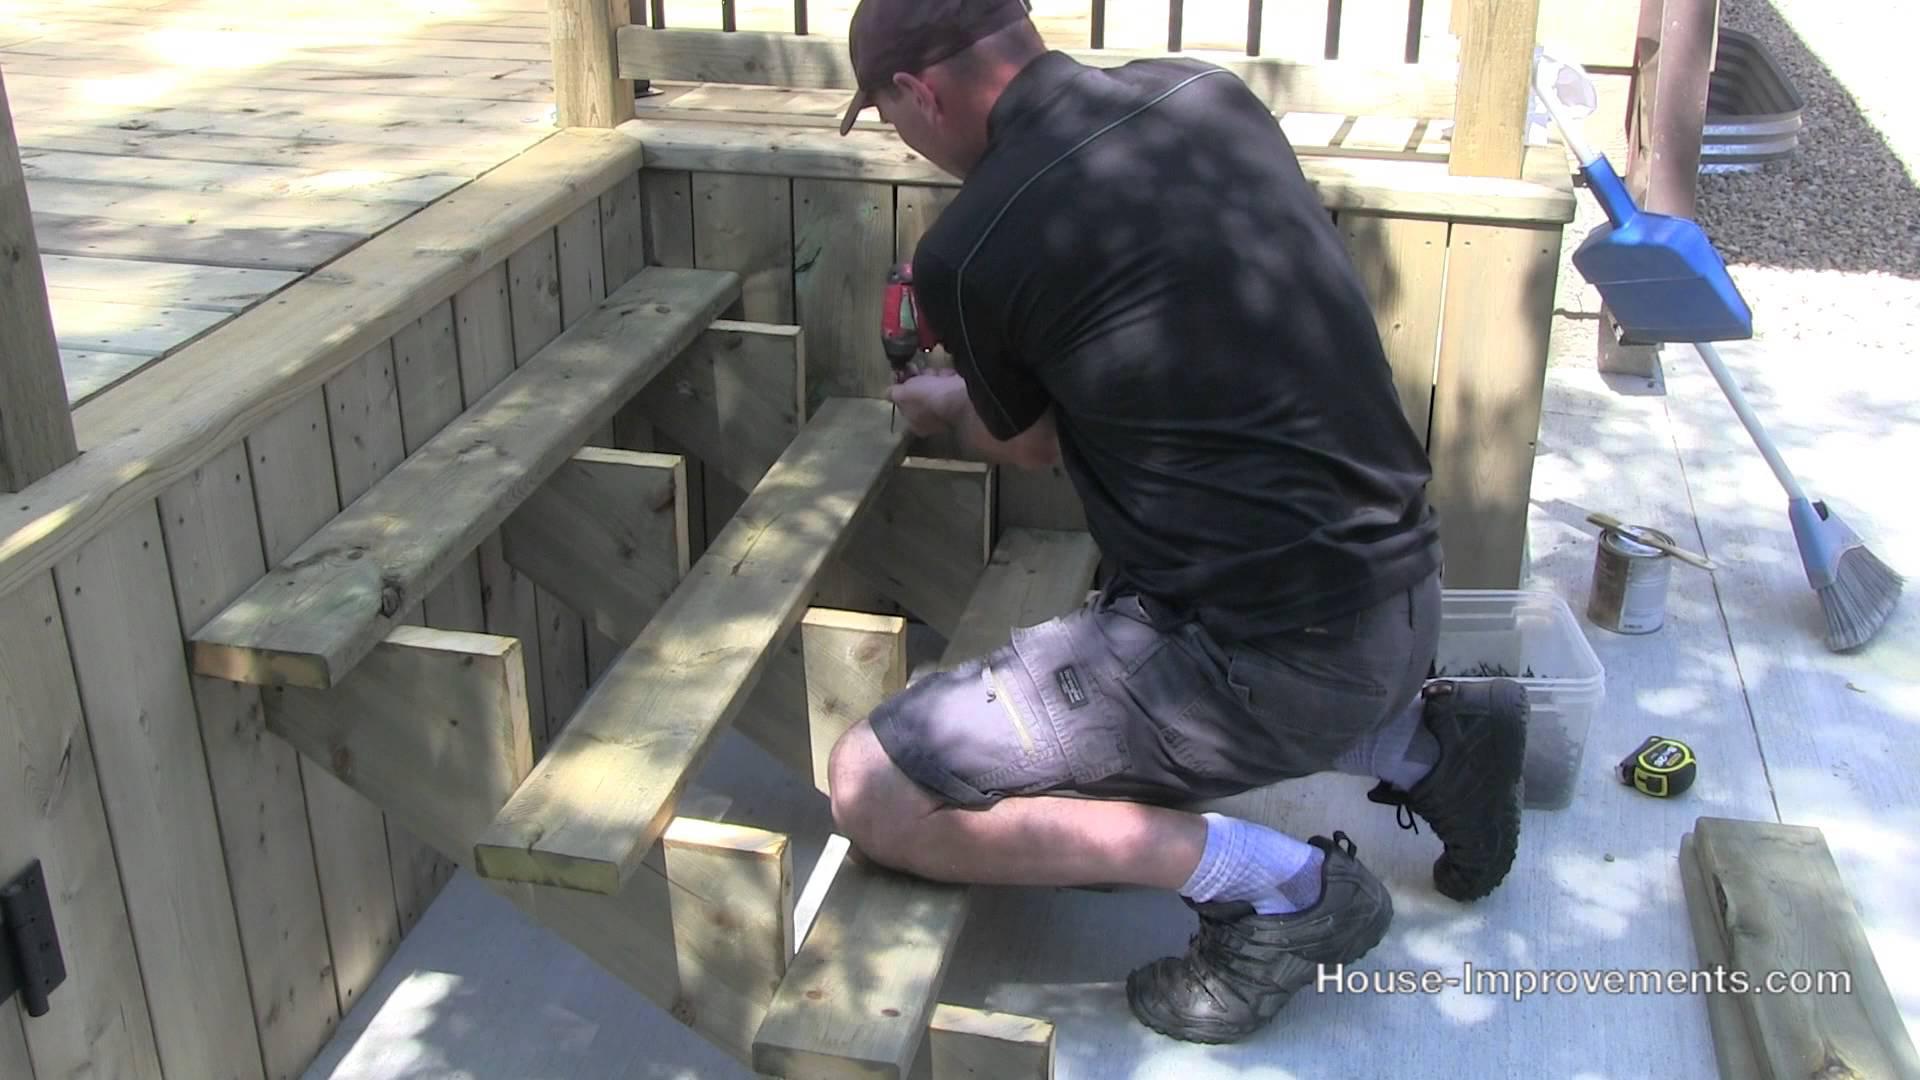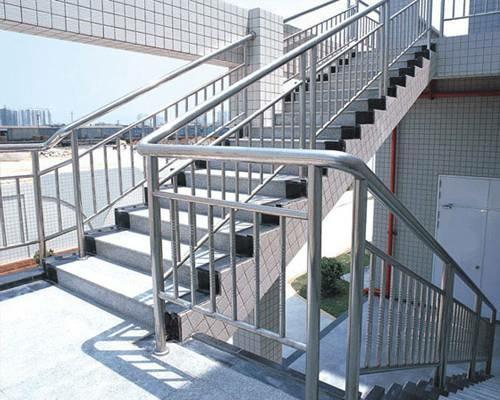The first image is the image on the left, the second image is the image on the right. For the images shown, is this caption "The left image contains one human doing carpentry." true? Answer yes or no. Yes. The first image is the image on the left, the second image is the image on the right. Examine the images to the left and right. Is the description "In one image, a wooden deck with ballustrade and set of stairs is outside the double doors of a house." accurate? Answer yes or no. No. 